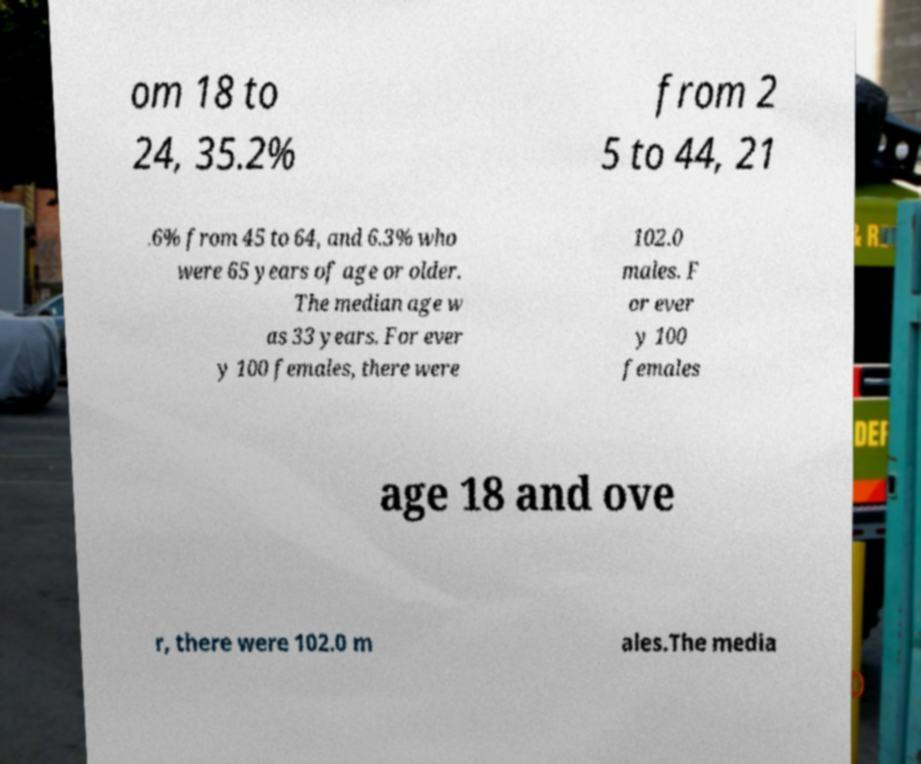For documentation purposes, I need the text within this image transcribed. Could you provide that? om 18 to 24, 35.2% from 2 5 to 44, 21 .6% from 45 to 64, and 6.3% who were 65 years of age or older. The median age w as 33 years. For ever y 100 females, there were 102.0 males. F or ever y 100 females age 18 and ove r, there were 102.0 m ales.The media 